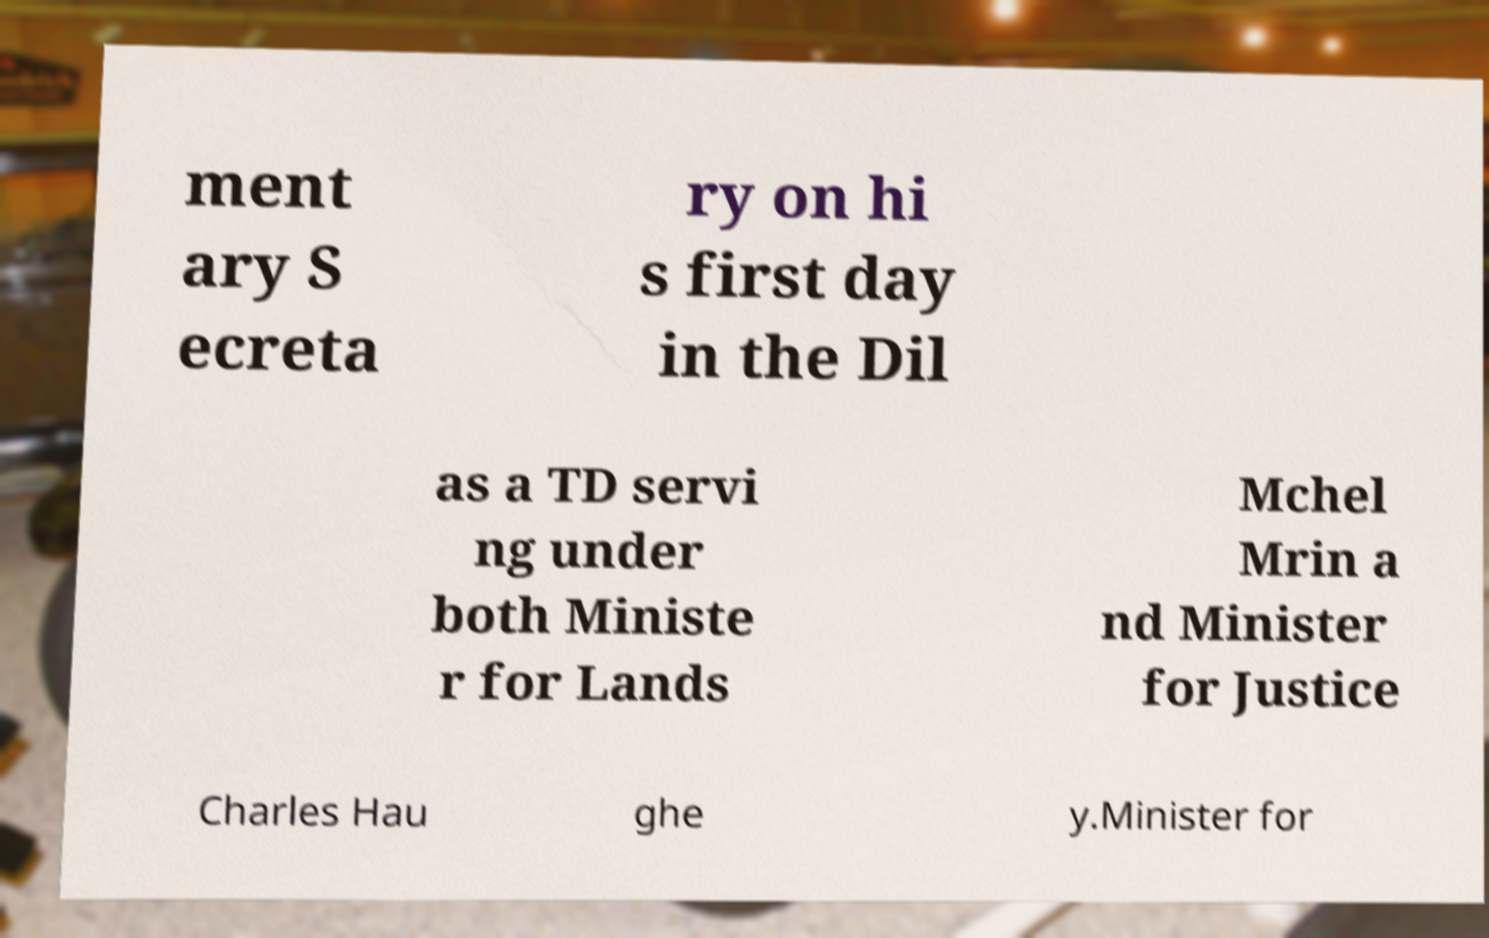Could you extract and type out the text from this image? ment ary S ecreta ry on hi s first day in the Dil as a TD servi ng under both Ministe r for Lands Mchel Mrin a nd Minister for Justice Charles Hau ghe y.Minister for 